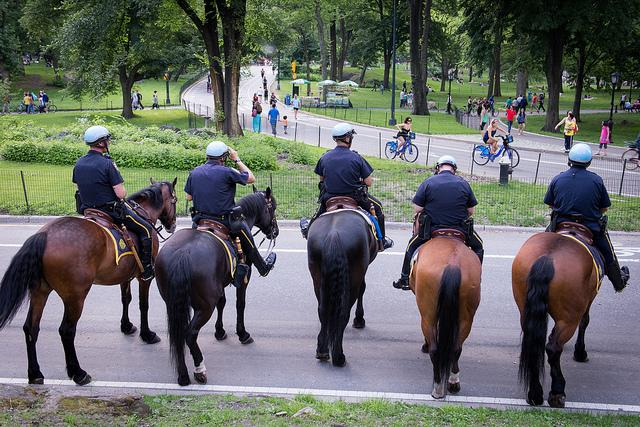What setting do these mounted persons stand in? park 